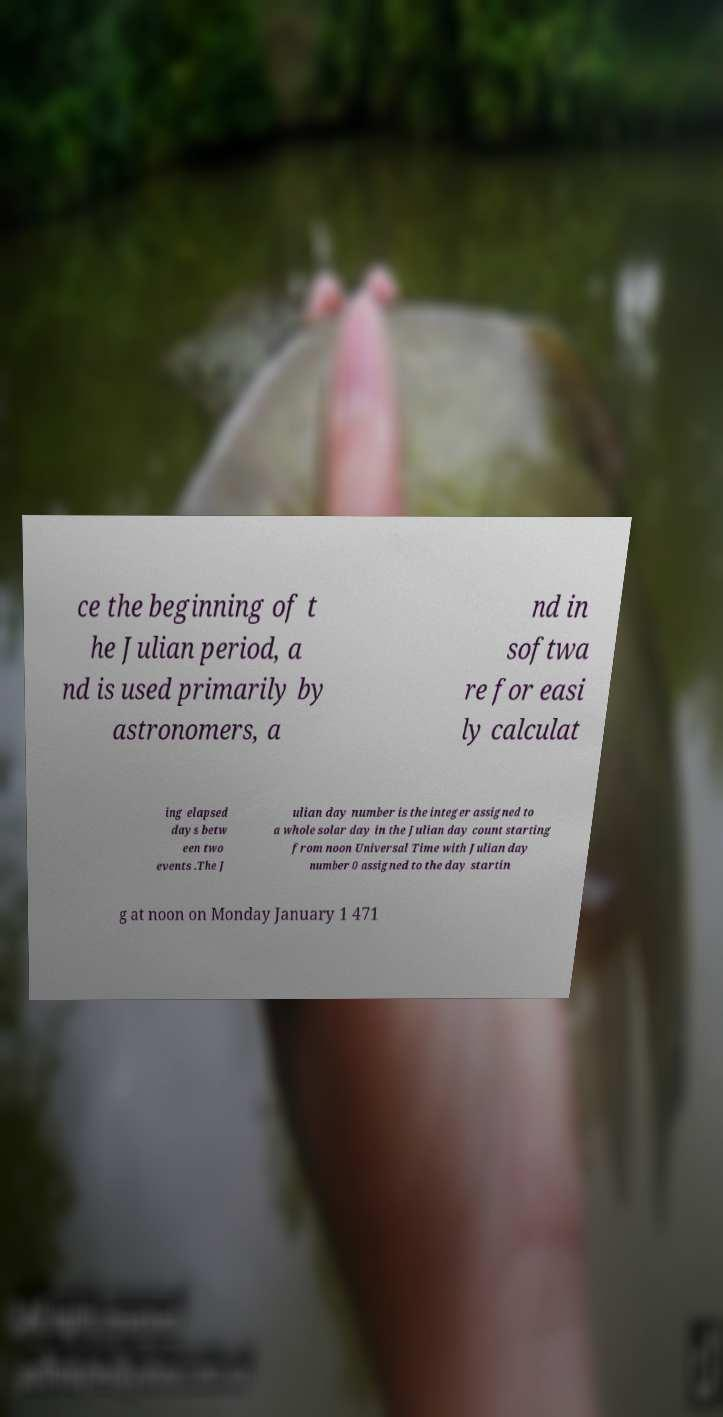For documentation purposes, I need the text within this image transcribed. Could you provide that? ce the beginning of t he Julian period, a nd is used primarily by astronomers, a nd in softwa re for easi ly calculat ing elapsed days betw een two events .The J ulian day number is the integer assigned to a whole solar day in the Julian day count starting from noon Universal Time with Julian day number 0 assigned to the day startin g at noon on Monday January 1 471 